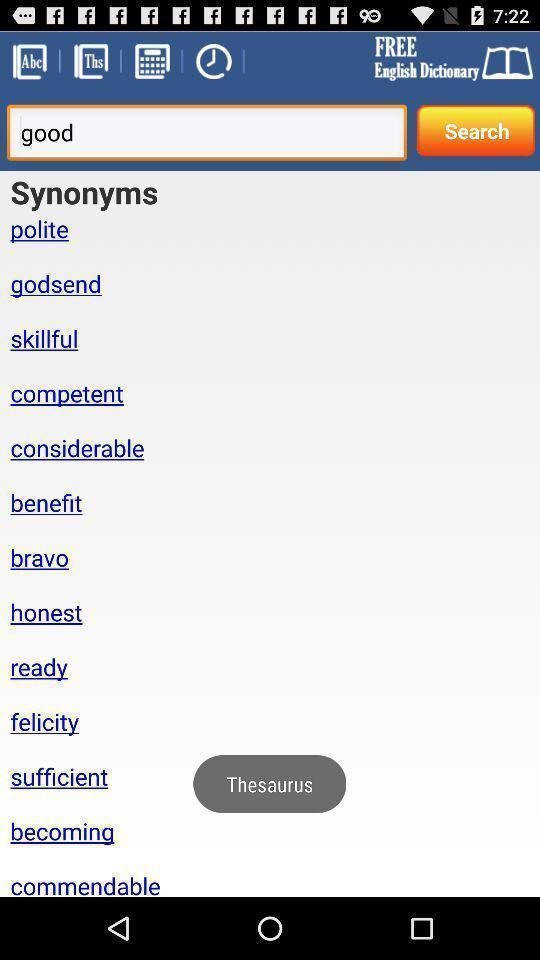Describe the content in this image. Screen page of a learning application. 